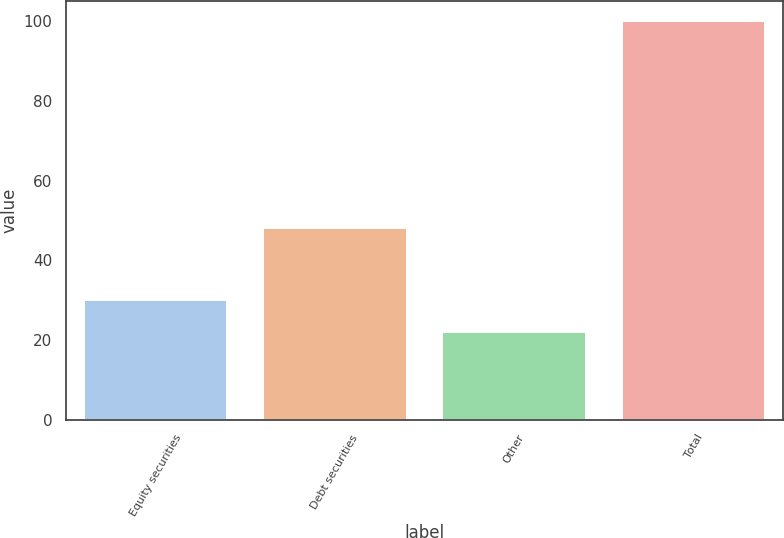<chart> <loc_0><loc_0><loc_500><loc_500><bar_chart><fcel>Equity securities<fcel>Debt securities<fcel>Other<fcel>Total<nl><fcel>30<fcel>48<fcel>22<fcel>100<nl></chart> 